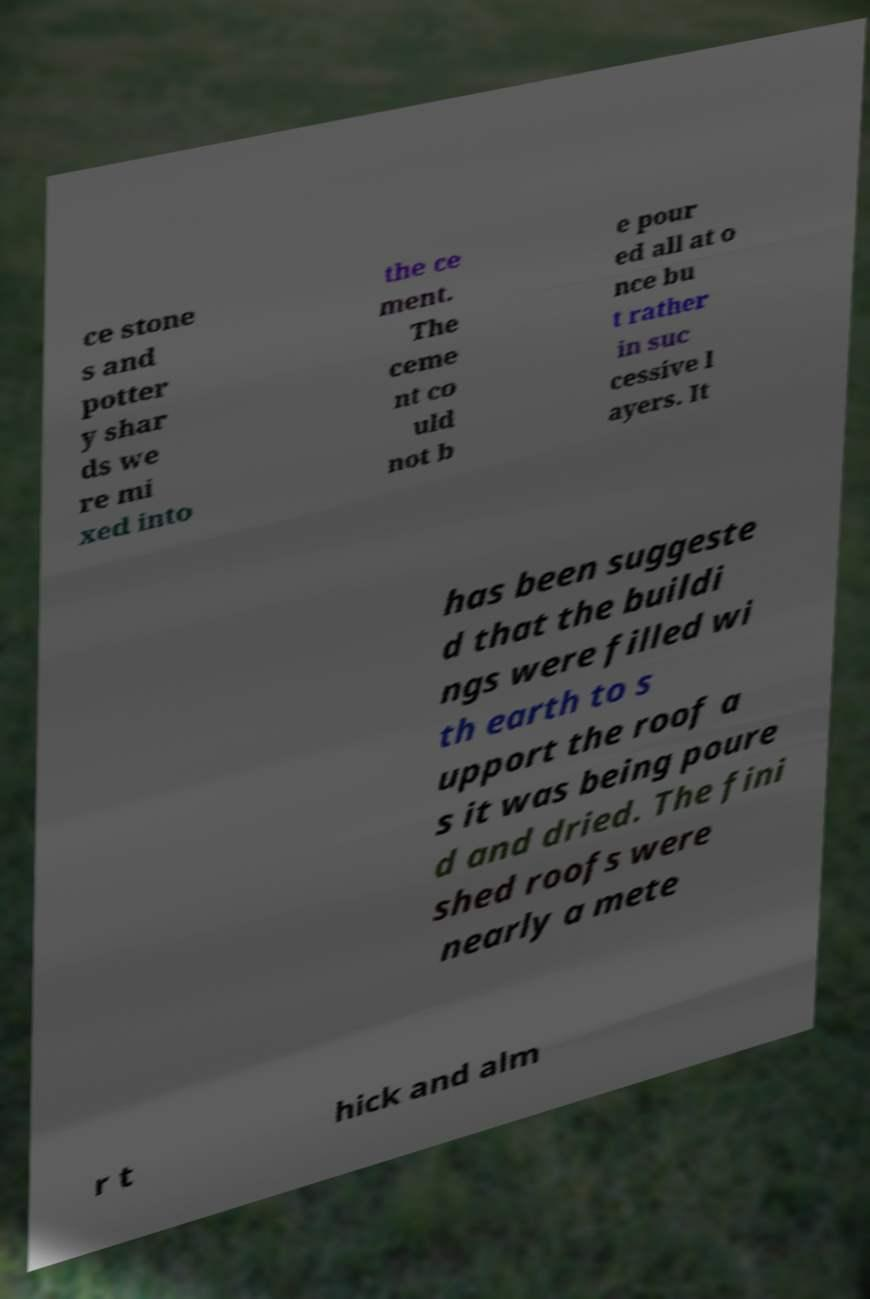Could you assist in decoding the text presented in this image and type it out clearly? ce stone s and potter y shar ds we re mi xed into the ce ment. The ceme nt co uld not b e pour ed all at o nce bu t rather in suc cessive l ayers. It has been suggeste d that the buildi ngs were filled wi th earth to s upport the roof a s it was being poure d and dried. The fini shed roofs were nearly a mete r t hick and alm 